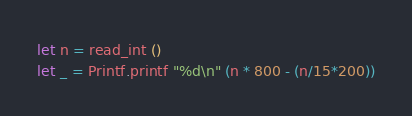<code> <loc_0><loc_0><loc_500><loc_500><_OCaml_>let n = read_int ()
let _ = Printf.printf "%d\n" (n * 800 - (n/15*200))</code> 